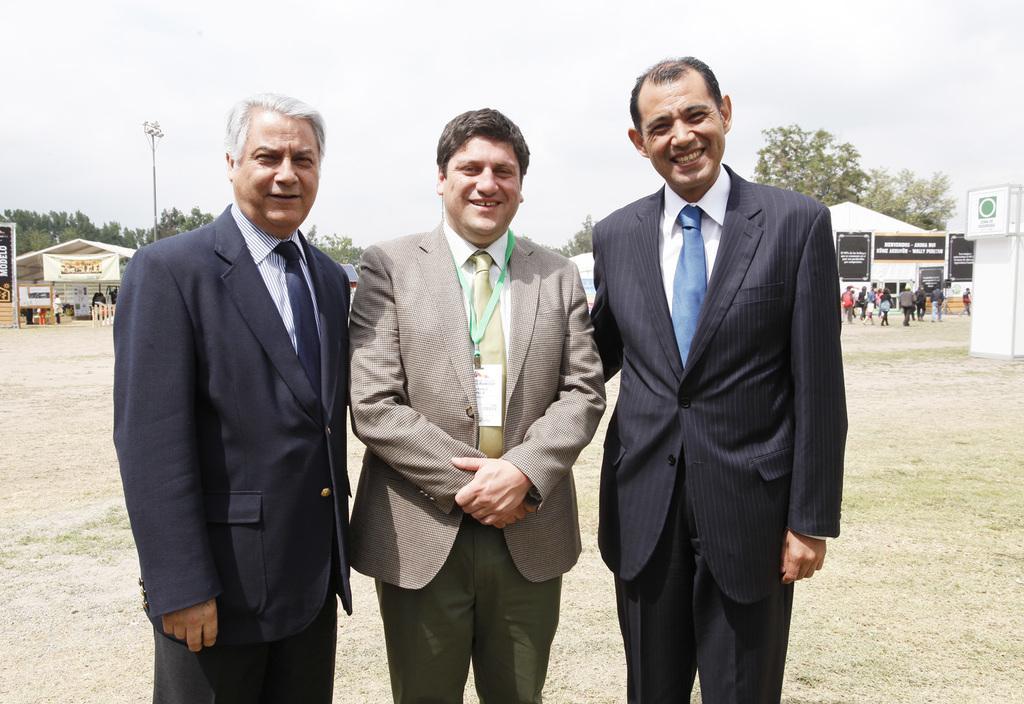How would you summarize this image in a sentence or two? In this image there are three persons wearing suit and standing on a ground, in the background there are sheds and there are people, trees, pole and a sky. 